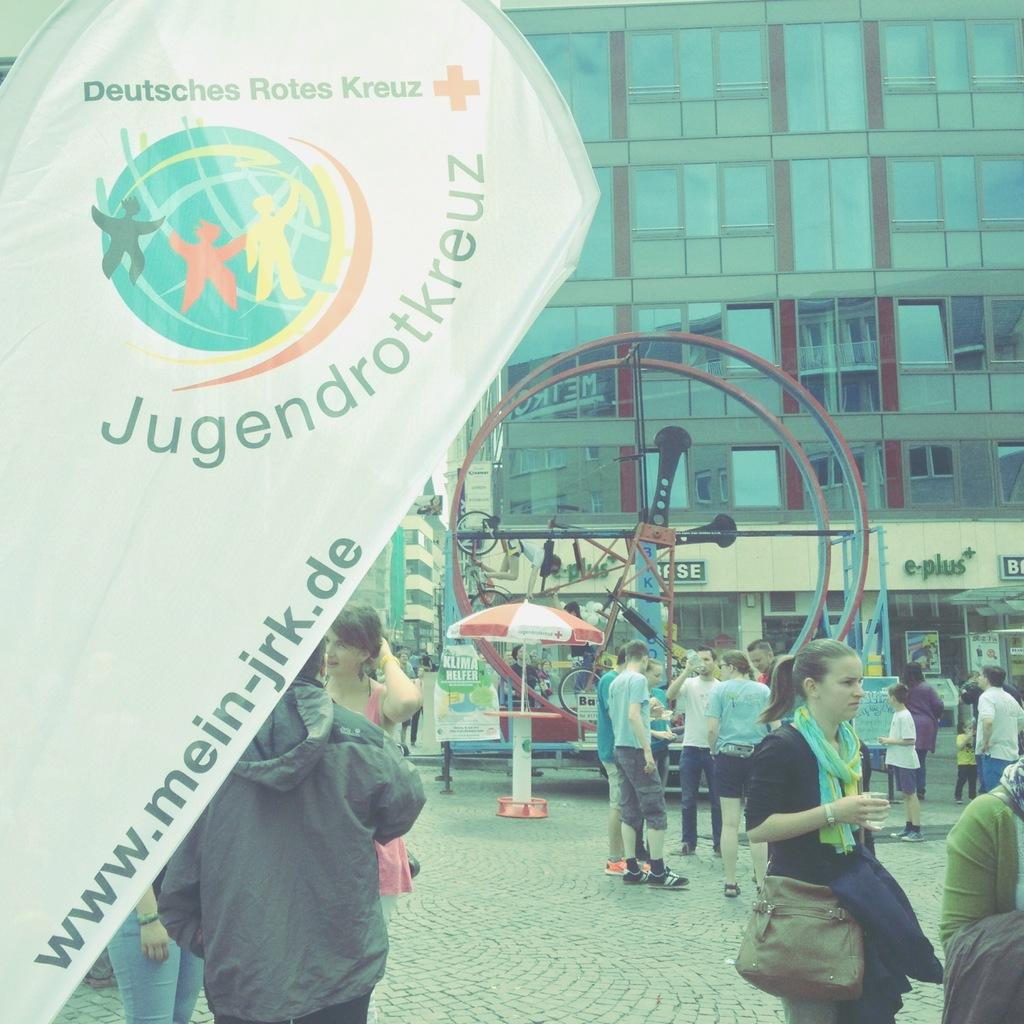What type of decorations can be seen in the image? There are banners in the image. What type of structures are visible in the image? There are buildings in the image. What object is used for protection from the elements in the image? There is an umbrella in the image. Can you describe the presence of people in the image? There are people present in the image. How many babies are crawling on the dirt in the image? There is no dirt or babies present in the image. What statement is being made by the people in the image? The image does not convey a specific statement; it simply shows the presence of people, banners, buildings, and an umbrella. 